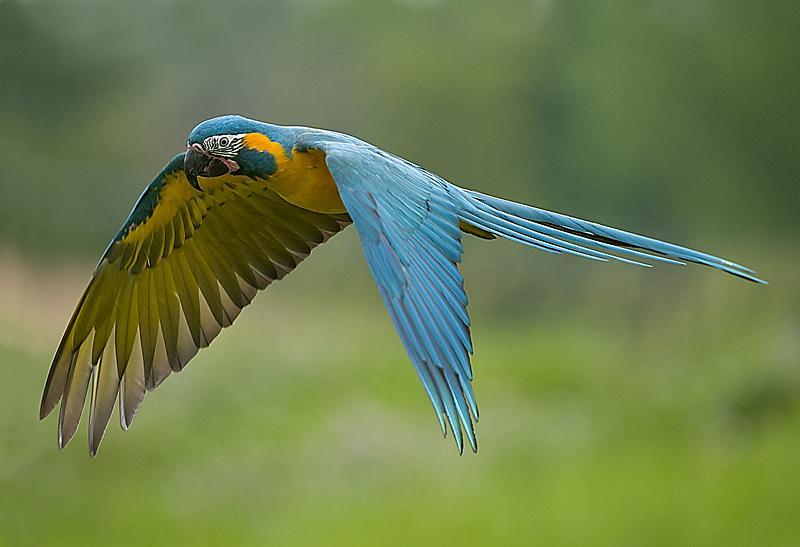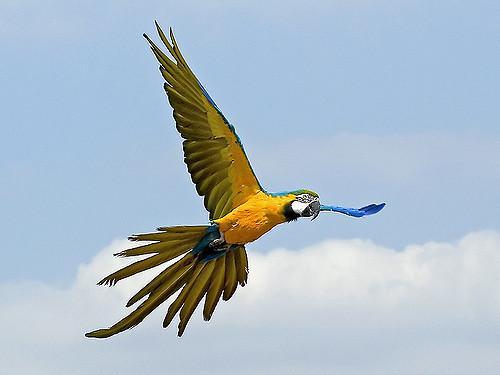The first image is the image on the left, the second image is the image on the right. Assess this claim about the two images: "There is one lone bird flying in one image and two birds flying together in the second.". Correct or not? Answer yes or no. No. The first image is the image on the left, the second image is the image on the right. Given the left and right images, does the statement "3 parrots are in flight in the image pair" hold true? Answer yes or no. No. 